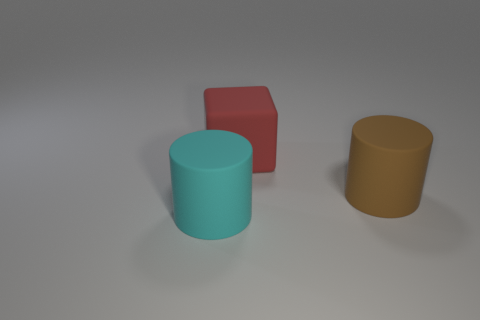Can you describe the lighting and shadows in the scene? The scene is illuminated from the upper left side, as indicated by the shadows cast to the right of the objects. The soft-edged shadows suggest a diffuse light source, creating a calm, even lighting across the scene. How does the lighting affect the mood of the image? The soft and diffuse lighting creates a tranquil and neutral atmosphere. It doesn't evoke a strong emotional response, allowing the focus to remain on the shapes and colors of the objects. 